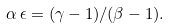<formula> <loc_0><loc_0><loc_500><loc_500>\alpha \, \epsilon = ( \gamma - 1 ) / ( \beta - 1 ) .</formula> 